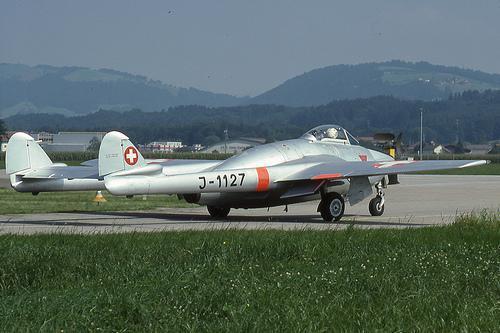How many planes do you see?
Give a very brief answer. 1. 